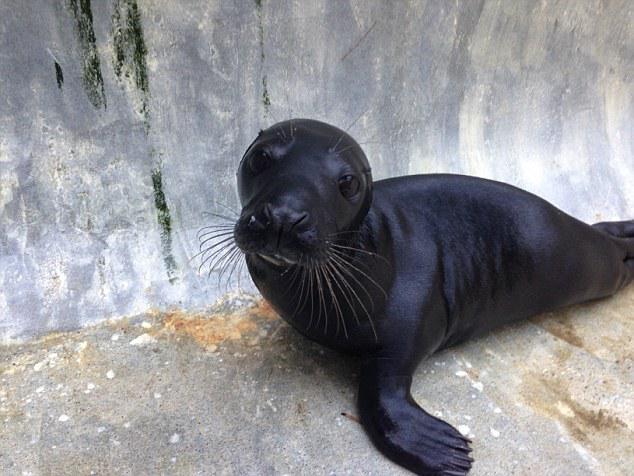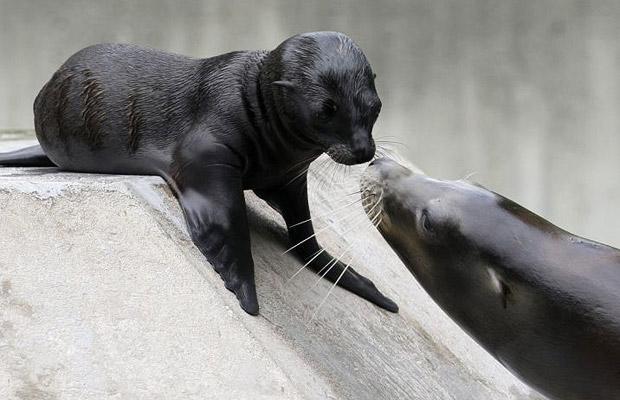The first image is the image on the left, the second image is the image on the right. Examine the images to the left and right. Is the description "Right image features one close-mouthed brown baby seal starting into the camera." accurate? Answer yes or no. No. The first image is the image on the left, the second image is the image on the right. For the images shown, is this caption "At least one sea lion is facing left" true? Answer yes or no. Yes. 